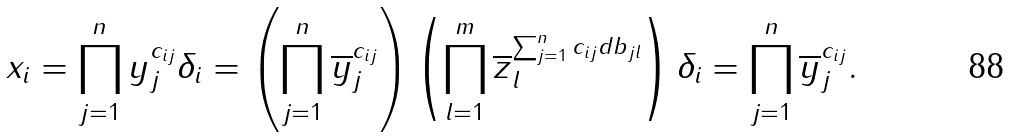Convert formula to latex. <formula><loc_0><loc_0><loc_500><loc_500>x _ { i } = \prod _ { j = 1 } ^ { n } y _ { j } ^ { c _ { i j } } \delta _ { i } = \left ( \prod _ { j = 1 } ^ { n } \overline { y } _ { j } ^ { c _ { i j } } \right ) \left ( \prod _ { l = 1 } ^ { m } \overline { z } _ { l } ^ { \sum _ { j = 1 } ^ { n } c _ { i j } d b _ { j l } } \right ) \delta _ { i } = \prod _ { j = 1 } ^ { n } \overline { y } _ { j } ^ { c _ { i j } } .</formula> 